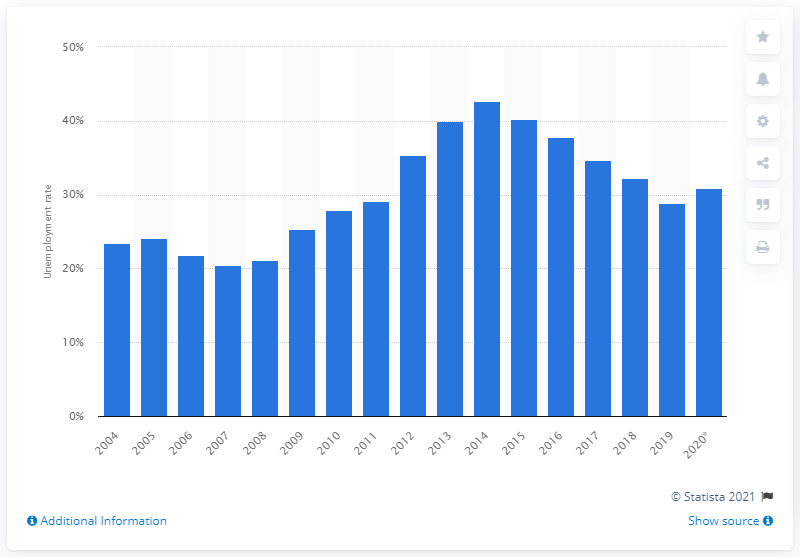List a handful of essential elements in this visual. The financial crisis in Italy began in 2008. 